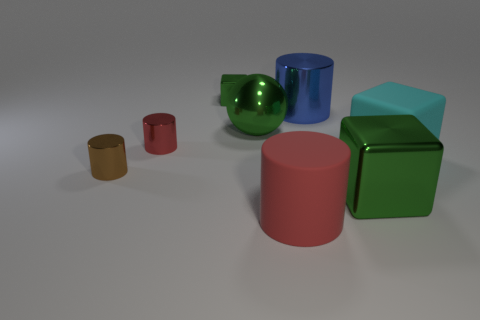The small green thing that is the same material as the blue object is what shape?
Ensure brevity in your answer.  Cube. What number of other objects are there of the same shape as the big blue metallic thing?
Provide a succinct answer. 3. What number of other objects are there of the same size as the red matte object?
Your response must be concise. 4. What is the material of the big green block on the right side of the green object left of the large green shiny object behind the brown thing?
Keep it short and to the point. Metal. There is a metallic ball; is it the same size as the red cylinder behind the big red cylinder?
Your answer should be compact. No. What is the size of the metal thing that is both behind the brown shiny thing and on the right side of the large red rubber thing?
Make the answer very short. Large. Is there a tiny metallic cylinder that has the same color as the large metal block?
Make the answer very short. No. What color is the metal cylinder that is to the right of the tiny shiny thing behind the shiny sphere?
Ensure brevity in your answer.  Blue. Is the number of green blocks that are in front of the small green metal thing less than the number of tiny metallic objects that are in front of the tiny brown shiny thing?
Make the answer very short. No. Do the blue metallic cylinder and the green shiny sphere have the same size?
Your answer should be very brief. Yes. 